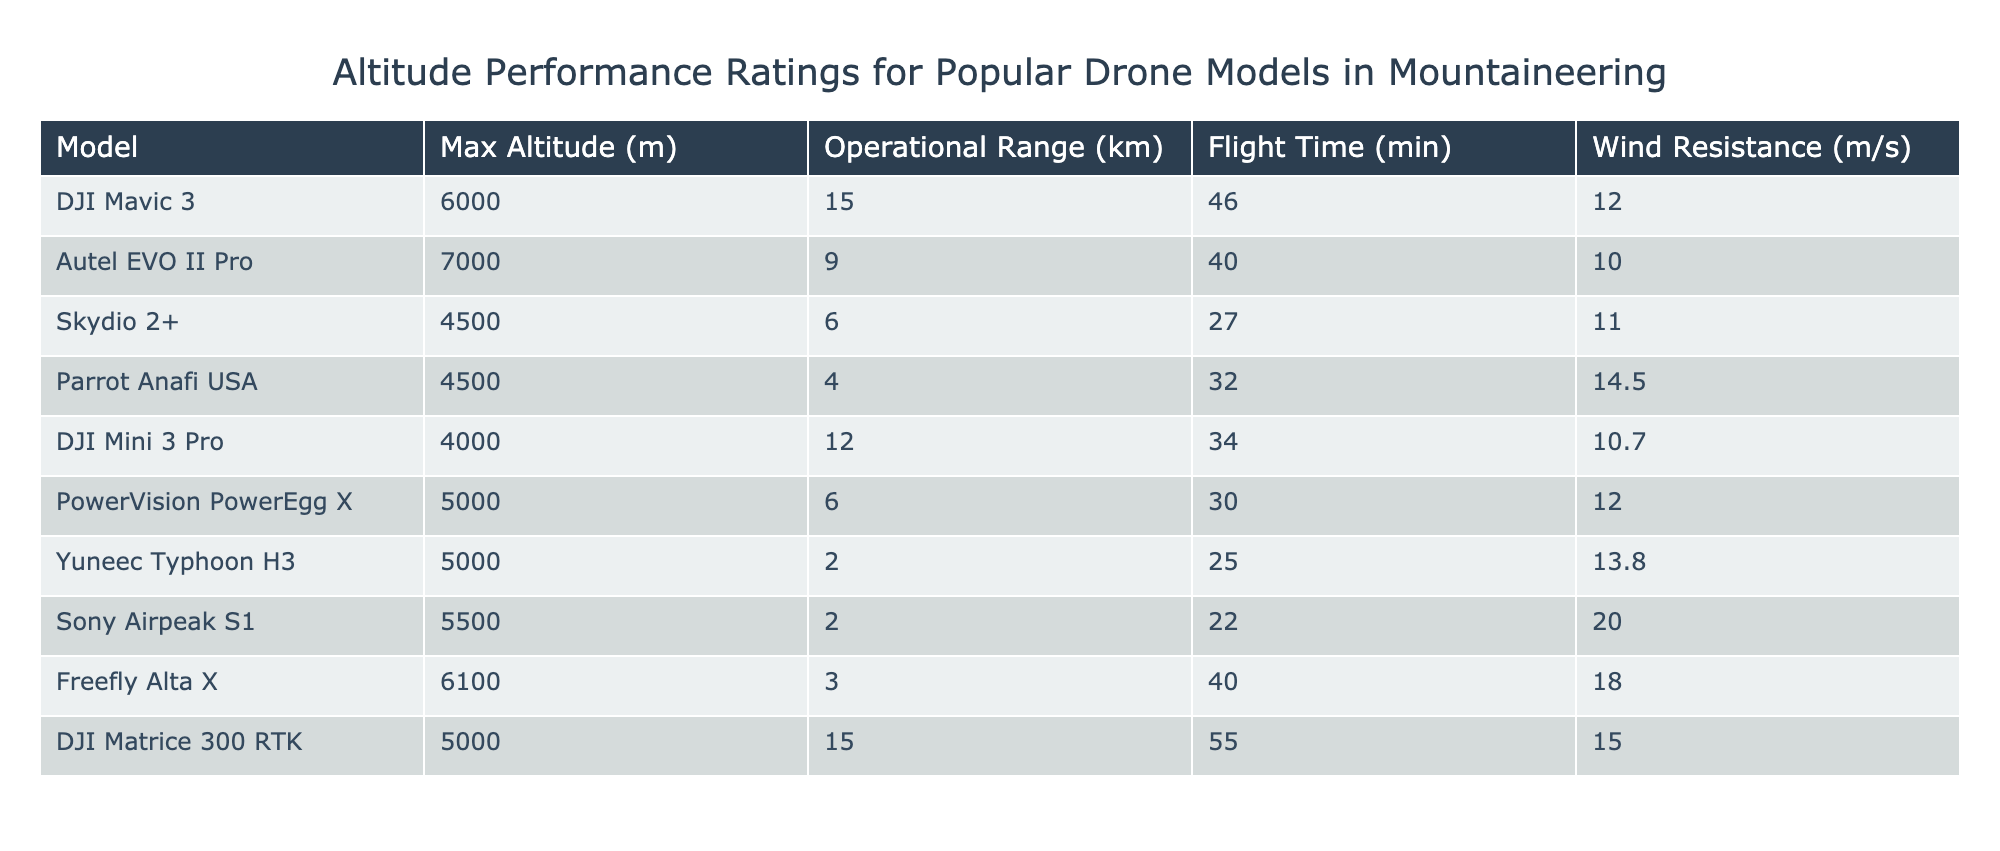What is the maximum altitude of the Autel EVO II Pro? The table lists the specifications of various drone models, and under the "Max Altitude (m)" column for the Autel EVO II Pro, the value is 7000 meters.
Answer: 7000 m Which drone has the highest flight time? Looking at the "Flight Time (min)" column, the DJI Matrice 300 RTK has the highest value at 55 minutes.
Answer: 55 min Is the DJI Mini 3 Pro better in wind resistance than the Parrot Anafi USA? The wind resistance for the DJI Mini 3 Pro is 10.7 m/s, while for the Parrot Anafi USA it is 14.5 m/s. Therefore, the Parrot Anafi USA is better in wind resistance.
Answer: No What is the average maximum altitude of all drones listed? To find the average maximum altitude, we first sum the maximum altitudes: 6000 + 7000 + 4500 + 4500 + 4000 + 5000 + 5000 + 5500 + 6100 + 5000 =  54500 meters. Then, we divide this by the number of drones (10): 54500 / 10 = 5450 meters.
Answer: 5450 m Which model has the longest operational range, and what is that range? Scanning the "Operational Range (km)" column, it shows that both the DJI Mavic 3 and DJI Matrice 300 RTK have a range of 15 km, which is the longest among all the listed models.
Answer: DJI Mavic 3 and DJI Matrice 300 RTK, 15 km How many drones can operate in wind speeds greater than 15 m/s? By examining the "Wind Resistance (m/s)" column, only the Sony Airpeak S1 with 20 m/s is greater than 15 m/s. Thus, there is only one drone.
Answer: 1 